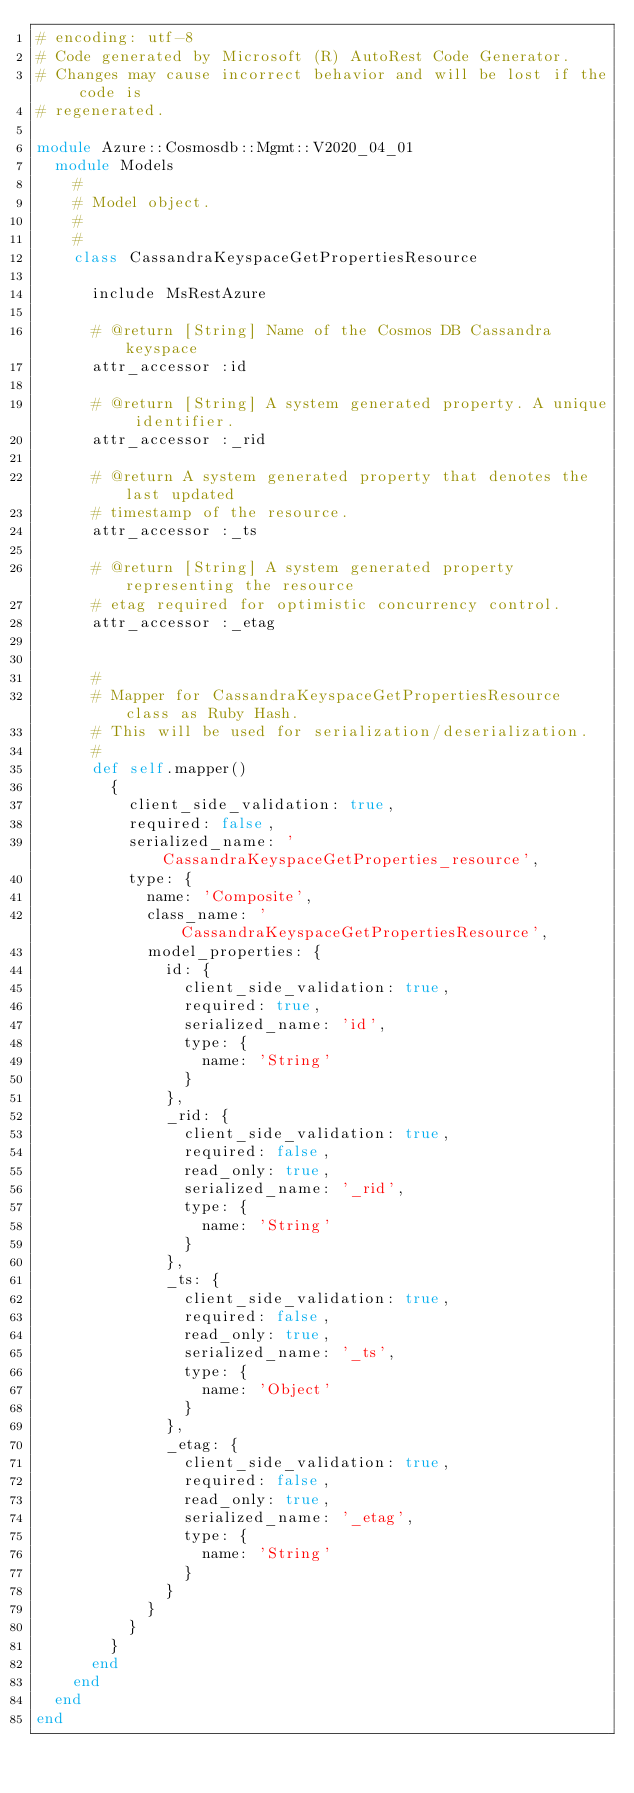Convert code to text. <code><loc_0><loc_0><loc_500><loc_500><_Ruby_># encoding: utf-8
# Code generated by Microsoft (R) AutoRest Code Generator.
# Changes may cause incorrect behavior and will be lost if the code is
# regenerated.

module Azure::Cosmosdb::Mgmt::V2020_04_01
  module Models
    #
    # Model object.
    #
    #
    class CassandraKeyspaceGetPropertiesResource

      include MsRestAzure

      # @return [String] Name of the Cosmos DB Cassandra keyspace
      attr_accessor :id

      # @return [String] A system generated property. A unique identifier.
      attr_accessor :_rid

      # @return A system generated property that denotes the last updated
      # timestamp of the resource.
      attr_accessor :_ts

      # @return [String] A system generated property representing the resource
      # etag required for optimistic concurrency control.
      attr_accessor :_etag


      #
      # Mapper for CassandraKeyspaceGetPropertiesResource class as Ruby Hash.
      # This will be used for serialization/deserialization.
      #
      def self.mapper()
        {
          client_side_validation: true,
          required: false,
          serialized_name: 'CassandraKeyspaceGetProperties_resource',
          type: {
            name: 'Composite',
            class_name: 'CassandraKeyspaceGetPropertiesResource',
            model_properties: {
              id: {
                client_side_validation: true,
                required: true,
                serialized_name: 'id',
                type: {
                  name: 'String'
                }
              },
              _rid: {
                client_side_validation: true,
                required: false,
                read_only: true,
                serialized_name: '_rid',
                type: {
                  name: 'String'
                }
              },
              _ts: {
                client_side_validation: true,
                required: false,
                read_only: true,
                serialized_name: '_ts',
                type: {
                  name: 'Object'
                }
              },
              _etag: {
                client_side_validation: true,
                required: false,
                read_only: true,
                serialized_name: '_etag',
                type: {
                  name: 'String'
                }
              }
            }
          }
        }
      end
    end
  end
end
</code> 